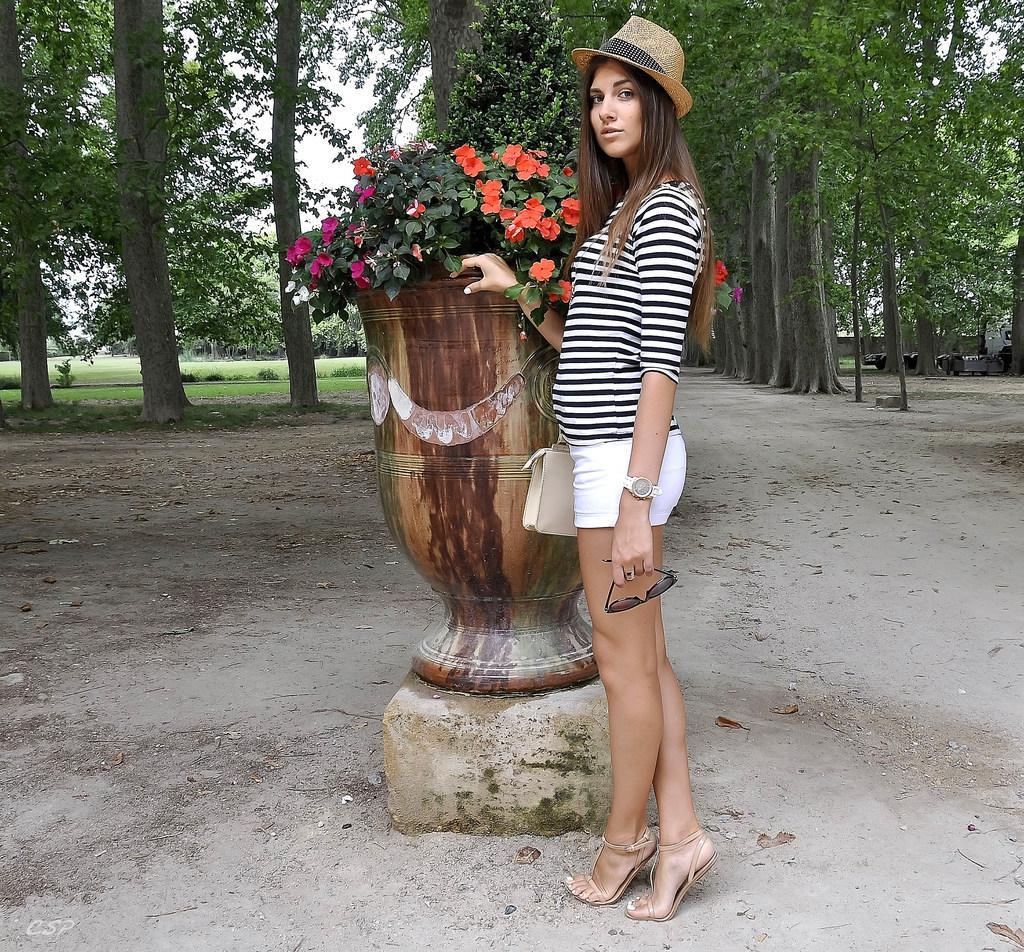In one or two sentences, can you explain what this image depicts? In this picture we can see a woman wore a hat, holding goggles with her hand, standing on the ground, pot with plants in it and in the background we can see the grass, trees, some objects and the sky. 